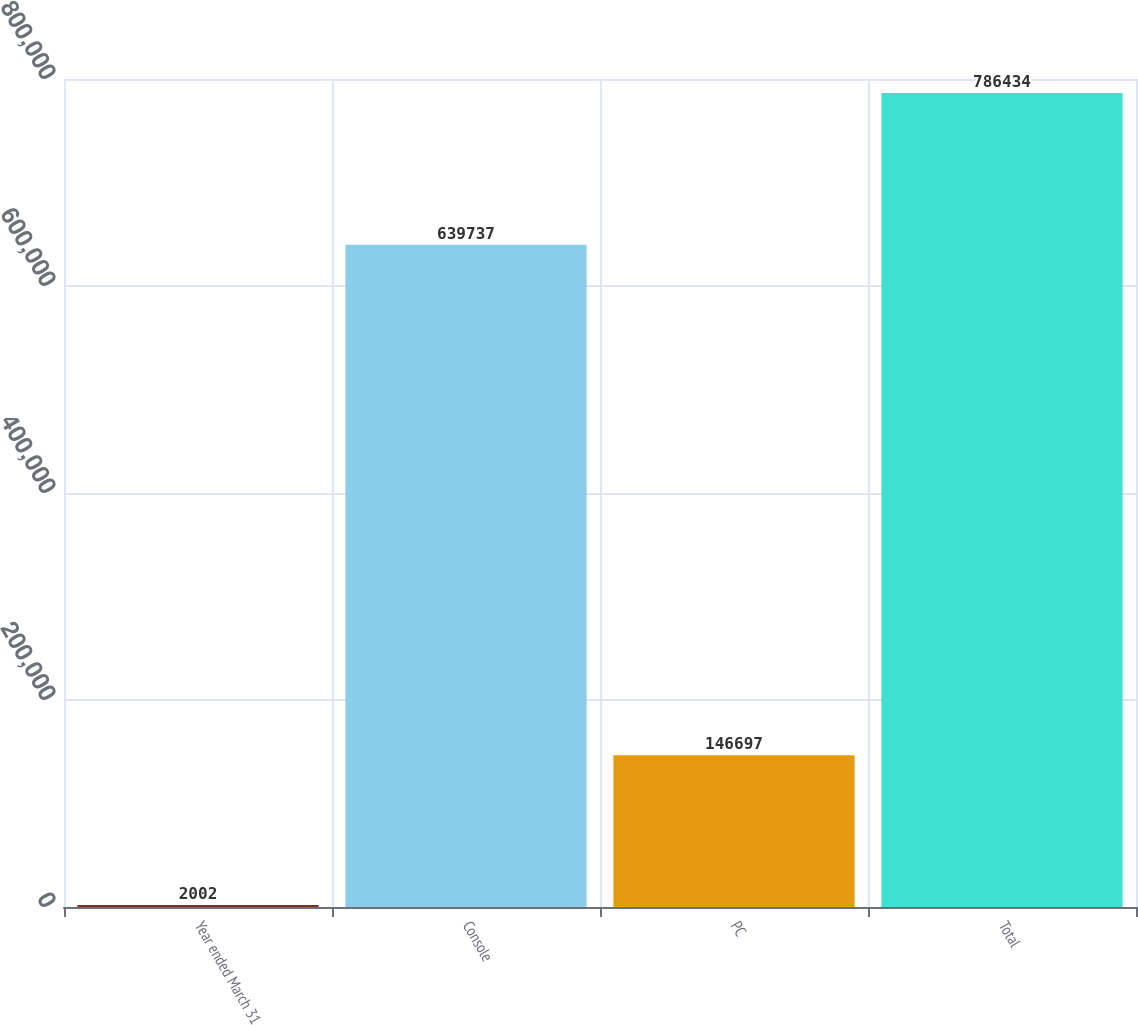Convert chart to OTSL. <chart><loc_0><loc_0><loc_500><loc_500><bar_chart><fcel>Year ended March 31<fcel>Console<fcel>PC<fcel>Total<nl><fcel>2002<fcel>639737<fcel>146697<fcel>786434<nl></chart> 